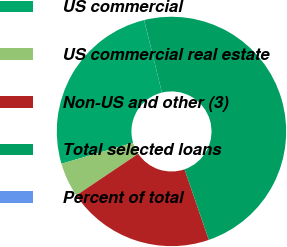<chart> <loc_0><loc_0><loc_500><loc_500><pie_chart><fcel>US commercial<fcel>US commercial real estate<fcel>Non-US and other (3)<fcel>Total selected loans<fcel>Percent of total<nl><fcel>25.71%<fcel>4.87%<fcel>20.86%<fcel>48.55%<fcel>0.01%<nl></chart> 